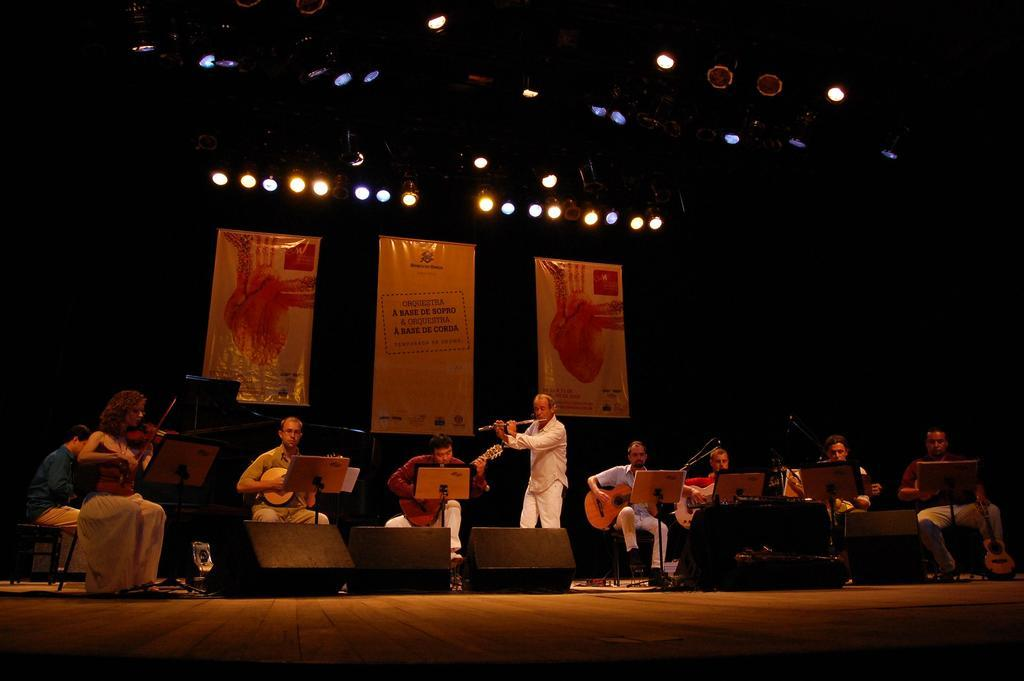What are the people in the image doing? The people in the image are playing musical instruments. What can be seen at the bottom of the image? There are speakers at the bottom of the image. What is visible in the background of the image? There are banners and lights in the background of the image. What type of structure is visible in the image? There are stands visible in the image. What type of coil can be seen in the image? There is no coil present in the image. How does the shame affect the performance of the musicians in the image? There is no mention of shame or any negative emotions in the image; the musicians are playing musical instruments. 